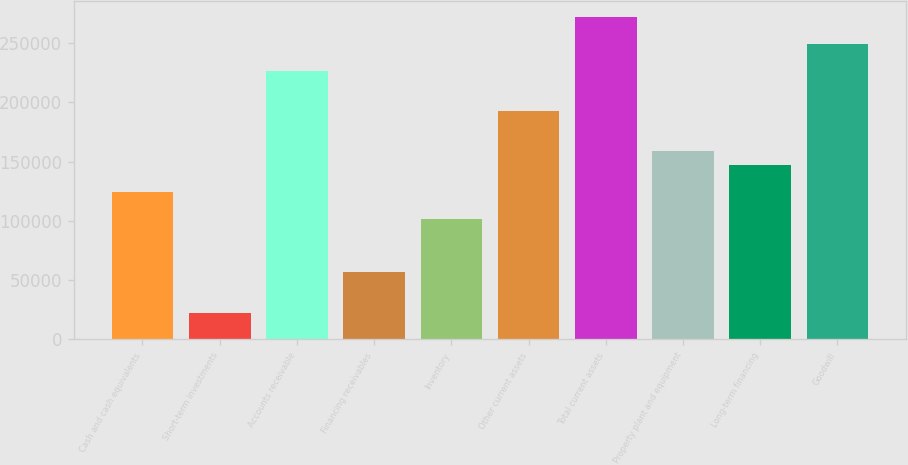<chart> <loc_0><loc_0><loc_500><loc_500><bar_chart><fcel>Cash and cash equivalents<fcel>Short-term investments<fcel>Accounts receivable<fcel>Financing receivables<fcel>Inventory<fcel>Other current assets<fcel>Total current assets<fcel>Property plant and equipment<fcel>Long-term financing<fcel>Goodwill<nl><fcel>124662<fcel>22685.4<fcel>226638<fcel>56677.5<fcel>102000<fcel>192646<fcel>271961<fcel>158654<fcel>147323<fcel>249299<nl></chart> 